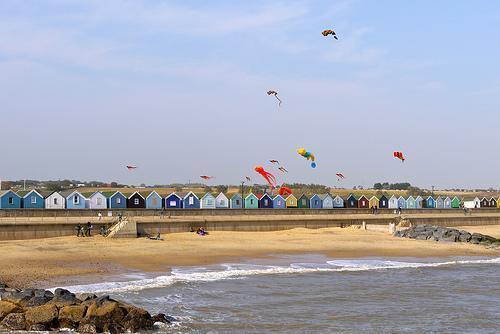How many kites are there?
Give a very brief answer. 11. 